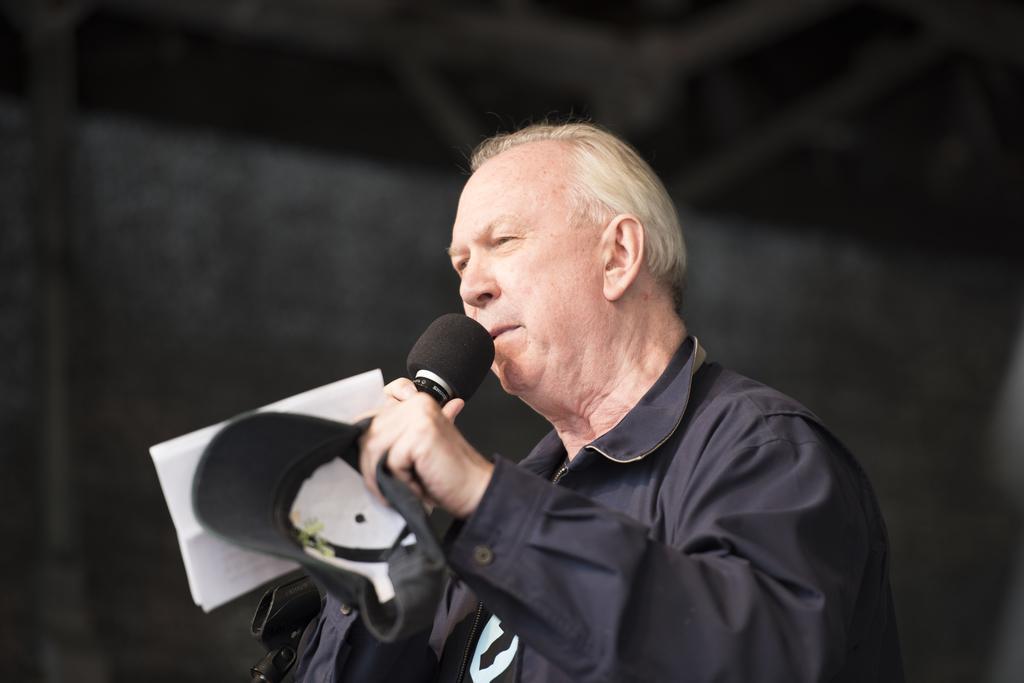Can you describe this image briefly? In this image a man is standing and holding a mic, a cap and a paper in his hands and he is talking. He is wearing a black jacket. 